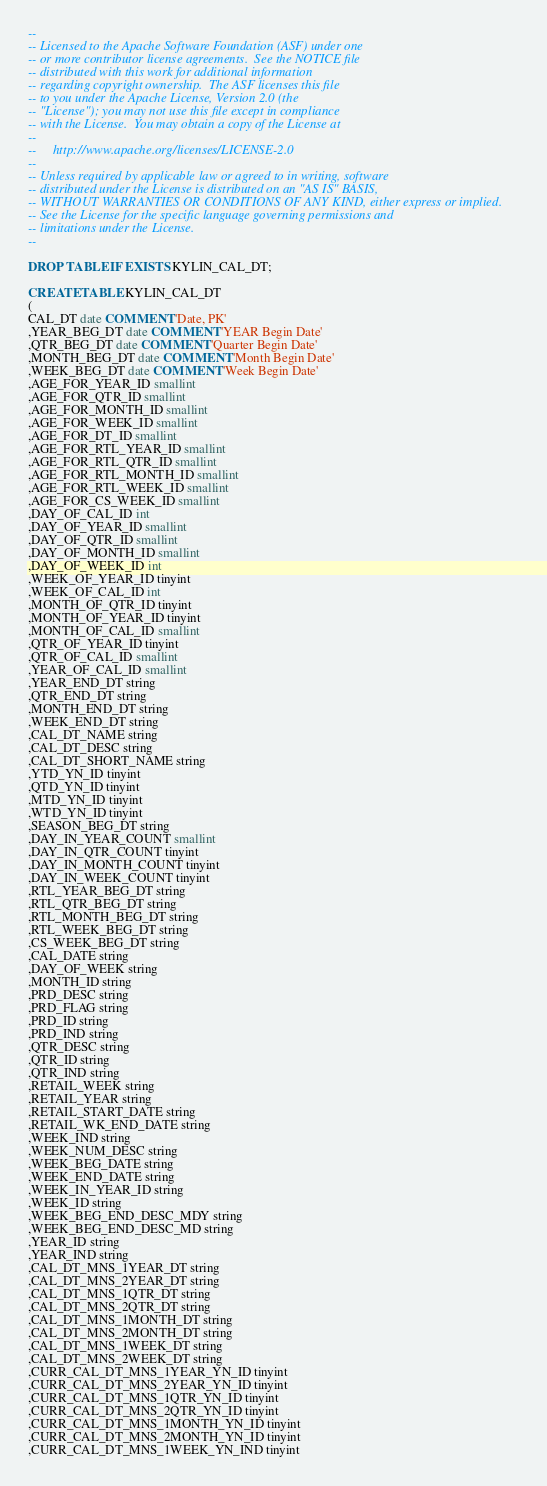<code> <loc_0><loc_0><loc_500><loc_500><_SQL_>--
-- Licensed to the Apache Software Foundation (ASF) under one
-- or more contributor license agreements.  See the NOTICE file
-- distributed with this work for additional information
-- regarding copyright ownership.  The ASF licenses this file
-- to you under the Apache License, Version 2.0 (the
-- "License"); you may not use this file except in compliance
-- with the License.  You may obtain a copy of the License at
--
--     http://www.apache.org/licenses/LICENSE-2.0
--
-- Unless required by applicable law or agreed to in writing, software
-- distributed under the License is distributed on an "AS IS" BASIS,
-- WITHOUT WARRANTIES OR CONDITIONS OF ANY KIND, either express or implied.
-- See the License for the specific language governing permissions and
-- limitations under the License.
--

DROP TABLE IF EXISTS KYLIN_CAL_DT;

CREATE TABLE KYLIN_CAL_DT
(
CAL_DT date COMMENT 'Date, PK'
,YEAR_BEG_DT date COMMENT 'YEAR Begin Date'
,QTR_BEG_DT date COMMENT 'Quarter Begin Date'
,MONTH_BEG_DT date COMMENT 'Month Begin Date'
,WEEK_BEG_DT date COMMENT 'Week Begin Date'
,AGE_FOR_YEAR_ID smallint
,AGE_FOR_QTR_ID smallint
,AGE_FOR_MONTH_ID smallint
,AGE_FOR_WEEK_ID smallint
,AGE_FOR_DT_ID smallint
,AGE_FOR_RTL_YEAR_ID smallint
,AGE_FOR_RTL_QTR_ID smallint
,AGE_FOR_RTL_MONTH_ID smallint
,AGE_FOR_RTL_WEEK_ID smallint
,AGE_FOR_CS_WEEK_ID smallint
,DAY_OF_CAL_ID int
,DAY_OF_YEAR_ID smallint
,DAY_OF_QTR_ID smallint
,DAY_OF_MONTH_ID smallint
,DAY_OF_WEEK_ID int
,WEEK_OF_YEAR_ID tinyint
,WEEK_OF_CAL_ID int
,MONTH_OF_QTR_ID tinyint
,MONTH_OF_YEAR_ID tinyint
,MONTH_OF_CAL_ID smallint
,QTR_OF_YEAR_ID tinyint
,QTR_OF_CAL_ID smallint
,YEAR_OF_CAL_ID smallint
,YEAR_END_DT string
,QTR_END_DT string
,MONTH_END_DT string
,WEEK_END_DT string
,CAL_DT_NAME string
,CAL_DT_DESC string
,CAL_DT_SHORT_NAME string
,YTD_YN_ID tinyint
,QTD_YN_ID tinyint
,MTD_YN_ID tinyint
,WTD_YN_ID tinyint
,SEASON_BEG_DT string
,DAY_IN_YEAR_COUNT smallint
,DAY_IN_QTR_COUNT tinyint
,DAY_IN_MONTH_COUNT tinyint
,DAY_IN_WEEK_COUNT tinyint
,RTL_YEAR_BEG_DT string
,RTL_QTR_BEG_DT string
,RTL_MONTH_BEG_DT string
,RTL_WEEK_BEG_DT string
,CS_WEEK_BEG_DT string
,CAL_DATE string
,DAY_OF_WEEK string
,MONTH_ID string
,PRD_DESC string
,PRD_FLAG string
,PRD_ID string
,PRD_IND string
,QTR_DESC string
,QTR_ID string
,QTR_IND string
,RETAIL_WEEK string
,RETAIL_YEAR string
,RETAIL_START_DATE string
,RETAIL_WK_END_DATE string
,WEEK_IND string
,WEEK_NUM_DESC string
,WEEK_BEG_DATE string
,WEEK_END_DATE string
,WEEK_IN_YEAR_ID string
,WEEK_ID string
,WEEK_BEG_END_DESC_MDY string
,WEEK_BEG_END_DESC_MD string
,YEAR_ID string
,YEAR_IND string
,CAL_DT_MNS_1YEAR_DT string
,CAL_DT_MNS_2YEAR_DT string
,CAL_DT_MNS_1QTR_DT string
,CAL_DT_MNS_2QTR_DT string
,CAL_DT_MNS_1MONTH_DT string
,CAL_DT_MNS_2MONTH_DT string
,CAL_DT_MNS_1WEEK_DT string
,CAL_DT_MNS_2WEEK_DT string
,CURR_CAL_DT_MNS_1YEAR_YN_ID tinyint
,CURR_CAL_DT_MNS_2YEAR_YN_ID tinyint
,CURR_CAL_DT_MNS_1QTR_YN_ID tinyint
,CURR_CAL_DT_MNS_2QTR_YN_ID tinyint
,CURR_CAL_DT_MNS_1MONTH_YN_ID tinyint
,CURR_CAL_DT_MNS_2MONTH_YN_ID tinyint
,CURR_CAL_DT_MNS_1WEEK_YN_IND tinyint</code> 